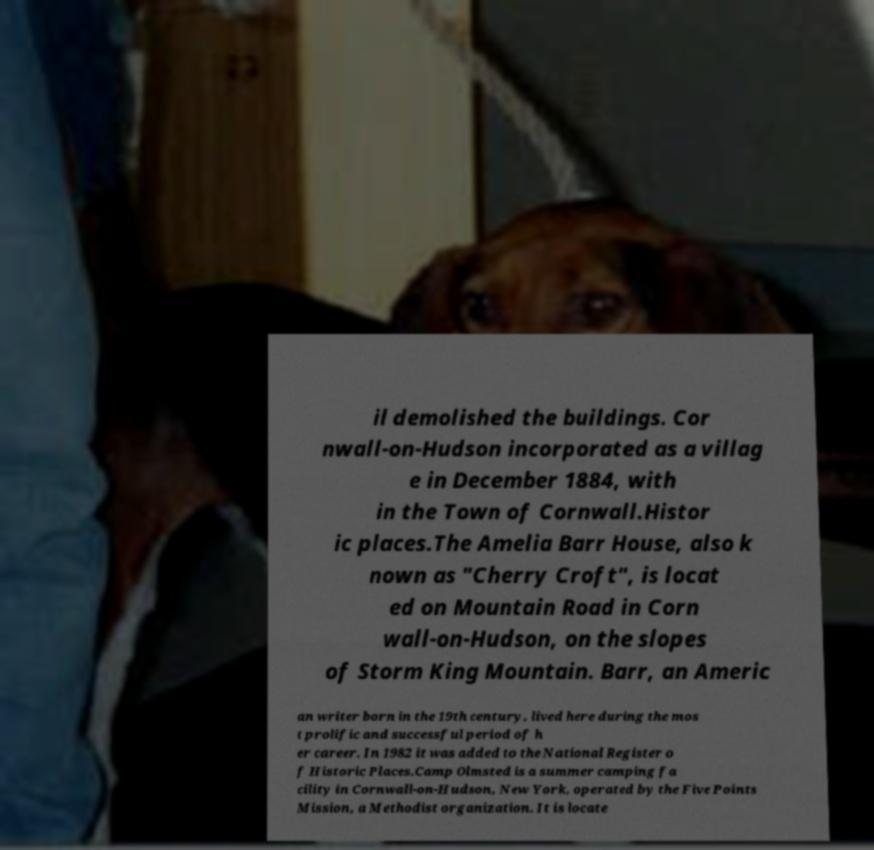Please read and relay the text visible in this image. What does it say? il demolished the buildings. Cor nwall-on-Hudson incorporated as a villag e in December 1884, with in the Town of Cornwall.Histor ic places.The Amelia Barr House, also k nown as "Cherry Croft", is locat ed on Mountain Road in Corn wall-on-Hudson, on the slopes of Storm King Mountain. Barr, an Americ an writer born in the 19th century, lived here during the mos t prolific and successful period of h er career. In 1982 it was added to the National Register o f Historic Places.Camp Olmsted is a summer camping fa cility in Cornwall-on-Hudson, New York, operated by the Five Points Mission, a Methodist organization. It is locate 